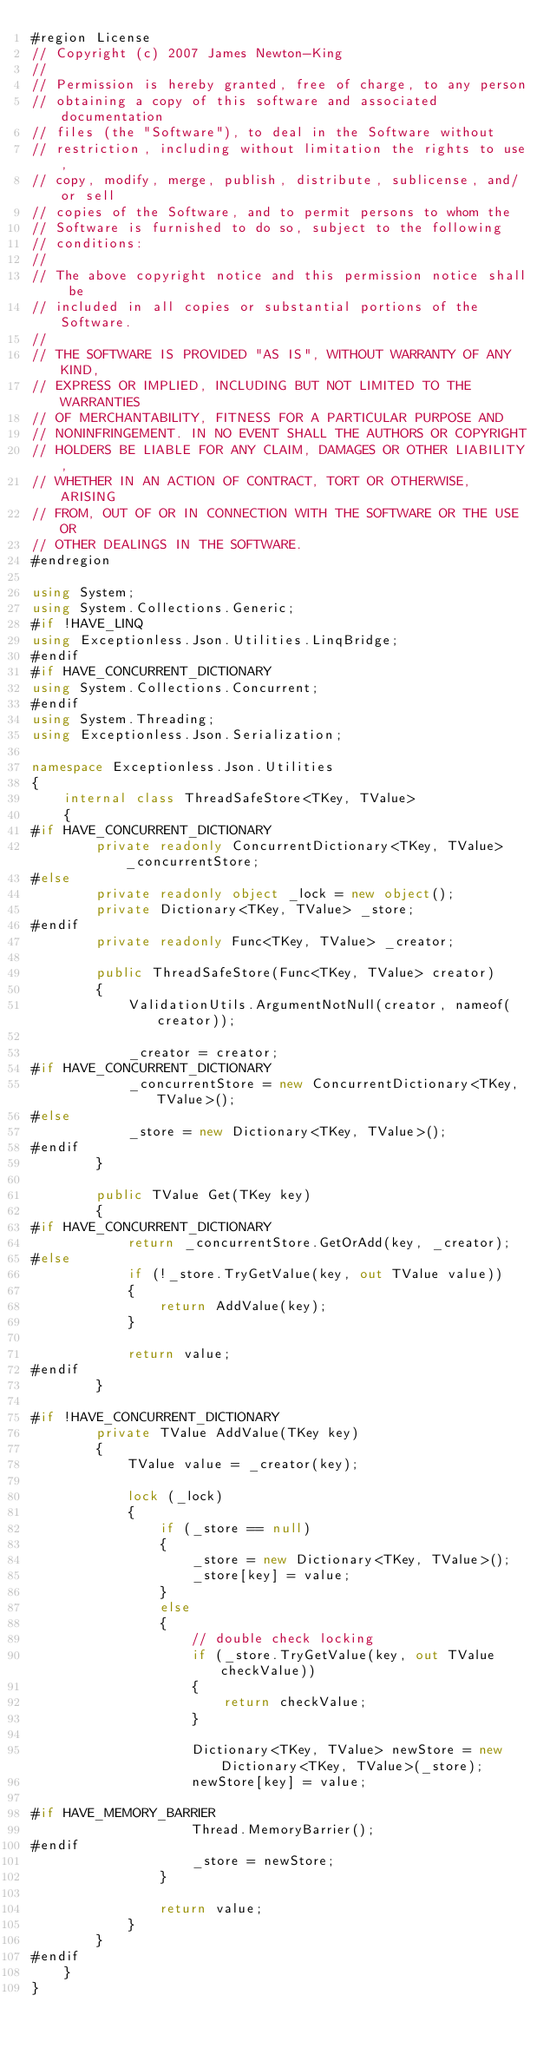Convert code to text. <code><loc_0><loc_0><loc_500><loc_500><_C#_>#region License
// Copyright (c) 2007 James Newton-King
//
// Permission is hereby granted, free of charge, to any person
// obtaining a copy of this software and associated documentation
// files (the "Software"), to deal in the Software without
// restriction, including without limitation the rights to use,
// copy, modify, merge, publish, distribute, sublicense, and/or sell
// copies of the Software, and to permit persons to whom the
// Software is furnished to do so, subject to the following
// conditions:
//
// The above copyright notice and this permission notice shall be
// included in all copies or substantial portions of the Software.
//
// THE SOFTWARE IS PROVIDED "AS IS", WITHOUT WARRANTY OF ANY KIND,
// EXPRESS OR IMPLIED, INCLUDING BUT NOT LIMITED TO THE WARRANTIES
// OF MERCHANTABILITY, FITNESS FOR A PARTICULAR PURPOSE AND
// NONINFRINGEMENT. IN NO EVENT SHALL THE AUTHORS OR COPYRIGHT
// HOLDERS BE LIABLE FOR ANY CLAIM, DAMAGES OR OTHER LIABILITY,
// WHETHER IN AN ACTION OF CONTRACT, TORT OR OTHERWISE, ARISING
// FROM, OUT OF OR IN CONNECTION WITH THE SOFTWARE OR THE USE OR
// OTHER DEALINGS IN THE SOFTWARE.
#endregion

using System;
using System.Collections.Generic;
#if !HAVE_LINQ
using Exceptionless.Json.Utilities.LinqBridge;
#endif
#if HAVE_CONCURRENT_DICTIONARY
using System.Collections.Concurrent;
#endif
using System.Threading;
using Exceptionless.Json.Serialization;

namespace Exceptionless.Json.Utilities
{
    internal class ThreadSafeStore<TKey, TValue>
    {
#if HAVE_CONCURRENT_DICTIONARY
        private readonly ConcurrentDictionary<TKey, TValue> _concurrentStore;
#else
        private readonly object _lock = new object();
        private Dictionary<TKey, TValue> _store;
#endif
        private readonly Func<TKey, TValue> _creator;

        public ThreadSafeStore(Func<TKey, TValue> creator)
        {
            ValidationUtils.ArgumentNotNull(creator, nameof(creator));

            _creator = creator;
#if HAVE_CONCURRENT_DICTIONARY
            _concurrentStore = new ConcurrentDictionary<TKey, TValue>();
#else
            _store = new Dictionary<TKey, TValue>();
#endif
        }

        public TValue Get(TKey key)
        {
#if HAVE_CONCURRENT_DICTIONARY
            return _concurrentStore.GetOrAdd(key, _creator);
#else
            if (!_store.TryGetValue(key, out TValue value))
            {
                return AddValue(key);
            }

            return value;
#endif
        }

#if !HAVE_CONCURRENT_DICTIONARY
        private TValue AddValue(TKey key)
        {
            TValue value = _creator(key);

            lock (_lock)
            {
                if (_store == null)
                {
                    _store = new Dictionary<TKey, TValue>();
                    _store[key] = value;
                }
                else
                {
                    // double check locking
                    if (_store.TryGetValue(key, out TValue checkValue))
                    {
                        return checkValue;
                    }

                    Dictionary<TKey, TValue> newStore = new Dictionary<TKey, TValue>(_store);
                    newStore[key] = value;

#if HAVE_MEMORY_BARRIER
                    Thread.MemoryBarrier();
#endif
                    _store = newStore;
                }

                return value;
            }
        }
#endif
    }
}
</code> 